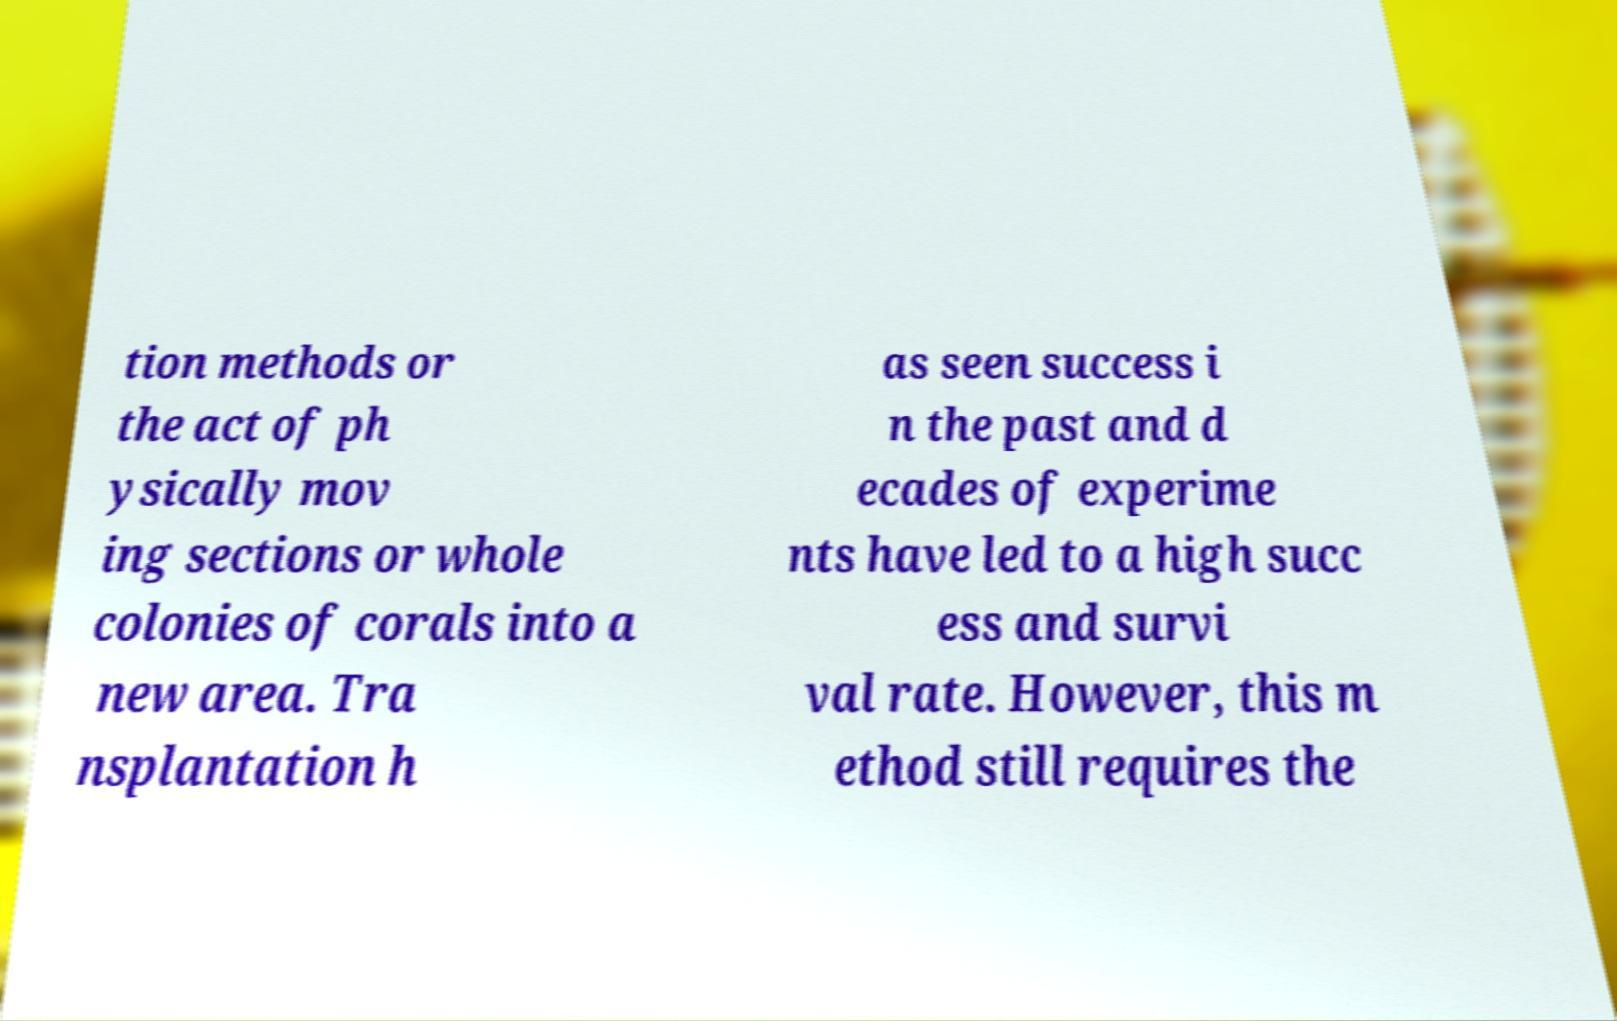Can you read and provide the text displayed in the image?This photo seems to have some interesting text. Can you extract and type it out for me? tion methods or the act of ph ysically mov ing sections or whole colonies of corals into a new area. Tra nsplantation h as seen success i n the past and d ecades of experime nts have led to a high succ ess and survi val rate. However, this m ethod still requires the 